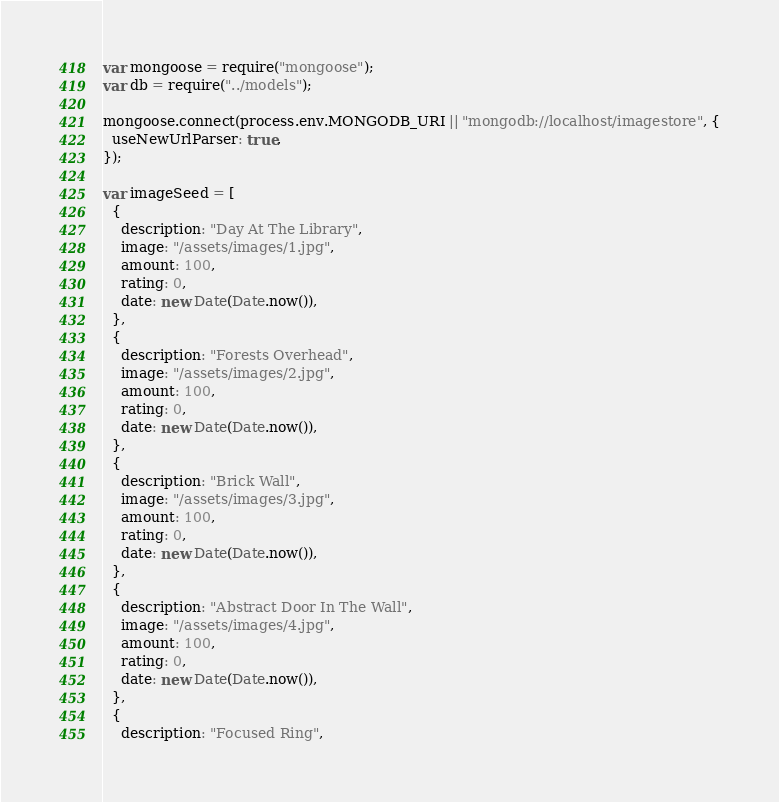Convert code to text. <code><loc_0><loc_0><loc_500><loc_500><_JavaScript_>var mongoose = require("mongoose");
var db = require("../models");

mongoose.connect(process.env.MONGODB_URI || "mongodb://localhost/imagestore", {
  useNewUrlParser: true,
});

var imageSeed = [
  {
    description: "Day At The Library",
    image: "/assets/images/1.jpg",
    amount: 100,
    rating: 0,
    date: new Date(Date.now()),
  },
  {
    description: "Forests Overhead",
    image: "/assets/images/2.jpg",
    amount: 100,
    rating: 0,
    date: new Date(Date.now()),
  },
  {
    description: "Brick Wall",
    image: "/assets/images/3.jpg",
    amount: 100,
    rating: 0,
    date: new Date(Date.now()),
  },
  {
    description: "Abstract Door In The Wall",
    image: "/assets/images/4.jpg",
    amount: 100,
    rating: 0,
    date: new Date(Date.now()),
  },
  {
    description: "Focused Ring",</code> 